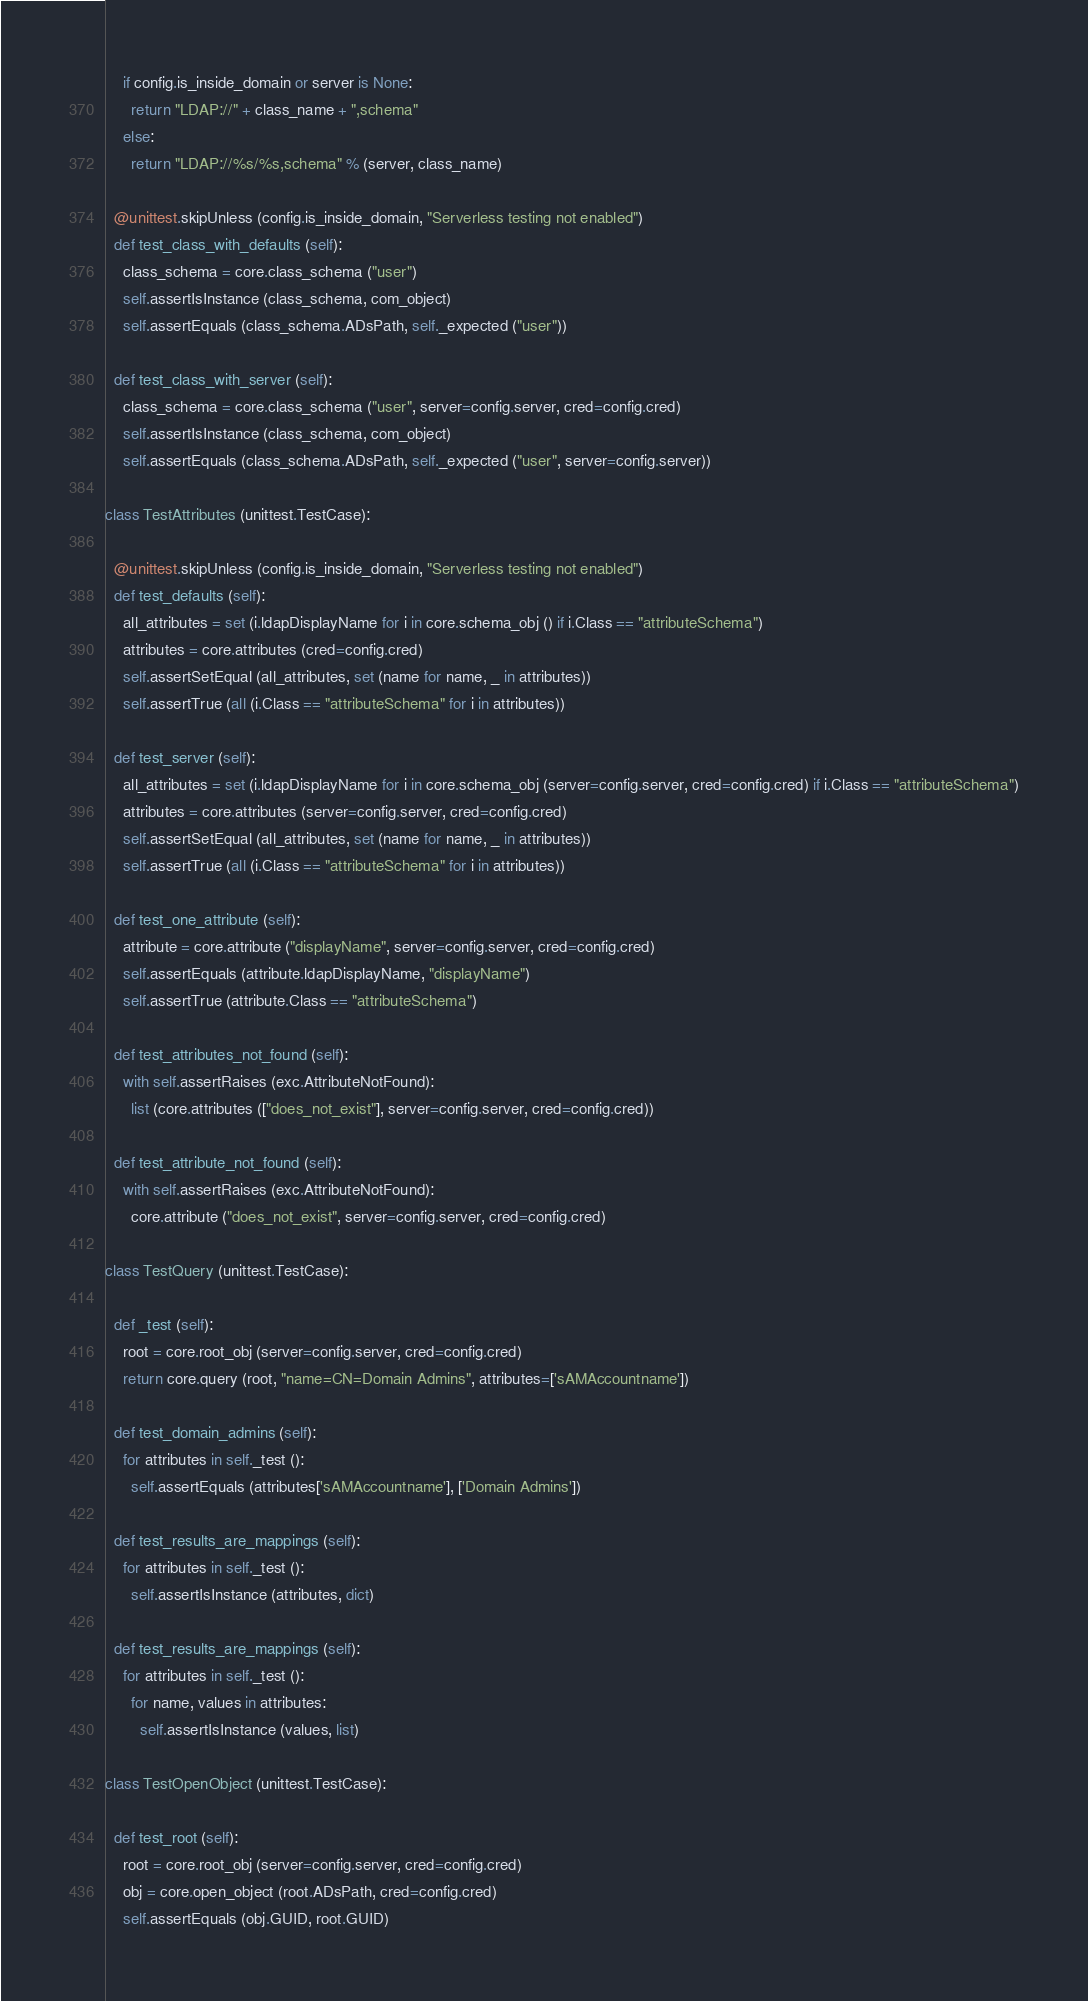<code> <loc_0><loc_0><loc_500><loc_500><_Python_>    if config.is_inside_domain or server is None:
      return "LDAP://" + class_name + ",schema"
    else:
      return "LDAP://%s/%s,schema" % (server, class_name)

  @unittest.skipUnless (config.is_inside_domain, "Serverless testing not enabled")
  def test_class_with_defaults (self):
    class_schema = core.class_schema ("user")
    self.assertIsInstance (class_schema, com_object)
    self.assertEquals (class_schema.ADsPath, self._expected ("user"))

  def test_class_with_server (self):
    class_schema = core.class_schema ("user", server=config.server, cred=config.cred)
    self.assertIsInstance (class_schema, com_object)
    self.assertEquals (class_schema.ADsPath, self._expected ("user", server=config.server))

class TestAttributes (unittest.TestCase):

  @unittest.skipUnless (config.is_inside_domain, "Serverless testing not enabled")
  def test_defaults (self):
    all_attributes = set (i.ldapDisplayName for i in core.schema_obj () if i.Class == "attributeSchema")
    attributes = core.attributes (cred=config.cred)
    self.assertSetEqual (all_attributes, set (name for name, _ in attributes))
    self.assertTrue (all (i.Class == "attributeSchema" for i in attributes))

  def test_server (self):
    all_attributes = set (i.ldapDisplayName for i in core.schema_obj (server=config.server, cred=config.cred) if i.Class == "attributeSchema")
    attributes = core.attributes (server=config.server, cred=config.cred)
    self.assertSetEqual (all_attributes, set (name for name, _ in attributes))
    self.assertTrue (all (i.Class == "attributeSchema" for i in attributes))

  def test_one_attribute (self):
    attribute = core.attribute ("displayName", server=config.server, cred=config.cred)
    self.assertEquals (attribute.ldapDisplayName, "displayName")
    self.assertTrue (attribute.Class == "attributeSchema")

  def test_attributes_not_found (self):
    with self.assertRaises (exc.AttributeNotFound):
      list (core.attributes (["does_not_exist"], server=config.server, cred=config.cred))

  def test_attribute_not_found (self):
    with self.assertRaises (exc.AttributeNotFound):
      core.attribute ("does_not_exist", server=config.server, cred=config.cred)

class TestQuery (unittest.TestCase):

  def _test (self):
    root = core.root_obj (server=config.server, cred=config.cred)
    return core.query (root, "name=CN=Domain Admins", attributes=['sAMAccountname'])

  def test_domain_admins (self):
    for attributes in self._test ():
      self.assertEquals (attributes['sAMAccountname'], ['Domain Admins'])

  def test_results_are_mappings (self):
    for attributes in self._test ():
      self.assertIsInstance (attributes, dict)

  def test_results_are_mappings (self):
    for attributes in self._test ():
      for name, values in attributes:
        self.assertIsInstance (values, list)

class TestOpenObject (unittest.TestCase):

  def test_root (self):
    root = core.root_obj (server=config.server, cred=config.cred)
    obj = core.open_object (root.ADsPath, cred=config.cred)
    self.assertEquals (obj.GUID, root.GUID)

</code> 